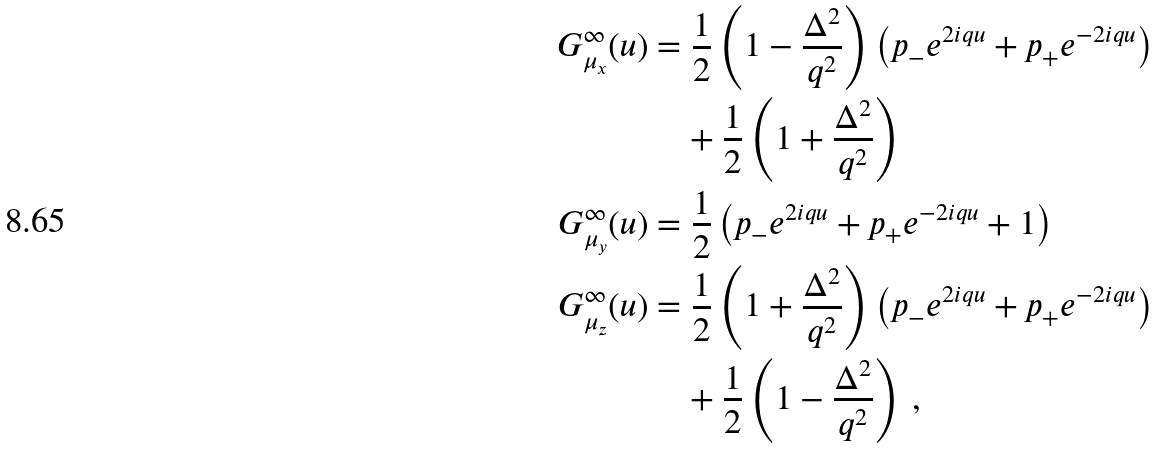Convert formula to latex. <formula><loc_0><loc_0><loc_500><loc_500>G ^ { \infty } _ { \mu _ { x } } ( u ) & = \frac { 1 } { 2 } \left ( 1 - \frac { \Delta ^ { 2 } } { q ^ { 2 } } \right ) \left ( p _ { - } e ^ { 2 i q u } + p _ { + } e ^ { - 2 i q u } \right ) \\ & \quad + \frac { 1 } { 2 } \left ( 1 + \frac { \Delta ^ { 2 } } { q ^ { 2 } } \right ) \\ G ^ { \infty } _ { \mu _ { y } } ( u ) & = \frac { 1 } { 2 } \left ( p _ { - } e ^ { 2 i q u } + p _ { + } e ^ { - 2 i q u } + 1 \right ) \\ G ^ { \infty } _ { \mu _ { z } } ( u ) & = \frac { 1 } { 2 } \left ( 1 + \frac { \Delta ^ { 2 } } { q ^ { 2 } } \right ) \left ( p _ { - } e ^ { 2 i q u } + p _ { + } e ^ { - 2 i q u } \right ) \\ & \quad + \frac { 1 } { 2 } \left ( 1 - \frac { \Delta ^ { 2 } } { q ^ { 2 } } \right ) \, , \\</formula> 